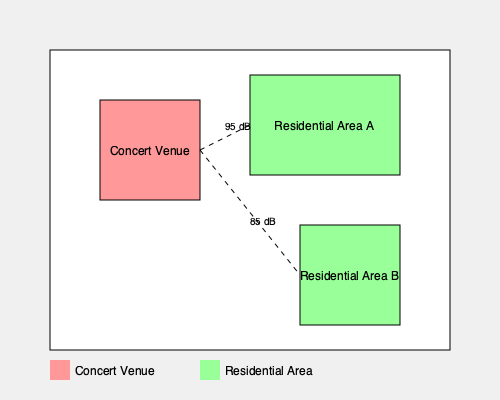As a community liaison officer, you are presented with a map showing a concert venue and two residential areas. The sound levels reaching Residential Area A and B are 95 dB and 85 dB, respectively. Given that the local noise ordinance limits sound levels in residential areas to 70 dB between 10 PM and 7 AM, what action should you recommend to ensure compliance while considering the artist's intention to perform? To address this situation, we need to consider several factors:

1. Legal requirement: The local noise ordinance limits sound levels to 70 dB in residential areas between 10 PM and 7 AM.

2. Current situation:
   - Residential Area A: 95 dB
   - Residential Area B: 85 dB
   Both areas exceed the legal limit.

3. Calculation of noise reduction needed:
   - For Area A: 95 dB - 70 dB = 25 dB reduction needed
   - For Area B: 85 dB - 70 dB = 15 dB reduction needed

4. Possible solutions:
   a) Reduce the overall volume of the concert
   b) Install sound barriers or improve existing ones
   c) Reposition speakers or stage to direct sound away from residential areas
   d) Limit concert hours to before 10 PM
   e) Relocate the concert venue

5. Considerations:
   - The artist's intention to perform must be balanced with legal requirements
   - The solution should aim to satisfy both the artist and the residents
   - The most practical and immediate solution is needed

6. Recommended action:
   Implement a combination of solutions to achieve compliance:
   - Reduce the overall volume of the concert to bring levels down by at least 15 dB
   - Install or improve sound barriers to further reduce noise levels
   - Reposition speakers to direct sound away from residential areas
   - If these measures are insufficient, limit the concert hours to end before 10 PM

This approach allows the concert to proceed while taking significant steps to reduce noise pollution and comply with local ordinances.
Answer: Reduce volume, install sound barriers, reposition speakers, and potentially limit concert hours to before 10 PM. 